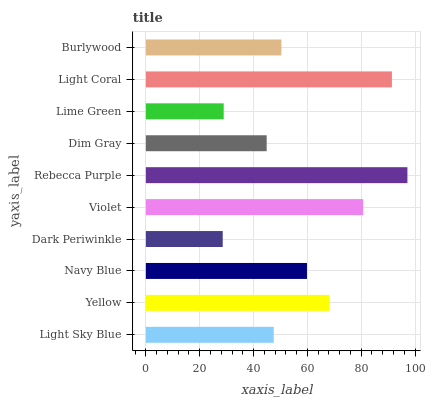Is Dark Periwinkle the minimum?
Answer yes or no. Yes. Is Rebecca Purple the maximum?
Answer yes or no. Yes. Is Yellow the minimum?
Answer yes or no. No. Is Yellow the maximum?
Answer yes or no. No. Is Yellow greater than Light Sky Blue?
Answer yes or no. Yes. Is Light Sky Blue less than Yellow?
Answer yes or no. Yes. Is Light Sky Blue greater than Yellow?
Answer yes or no. No. Is Yellow less than Light Sky Blue?
Answer yes or no. No. Is Navy Blue the high median?
Answer yes or no. Yes. Is Burlywood the low median?
Answer yes or no. Yes. Is Light Coral the high median?
Answer yes or no. No. Is Violet the low median?
Answer yes or no. No. 